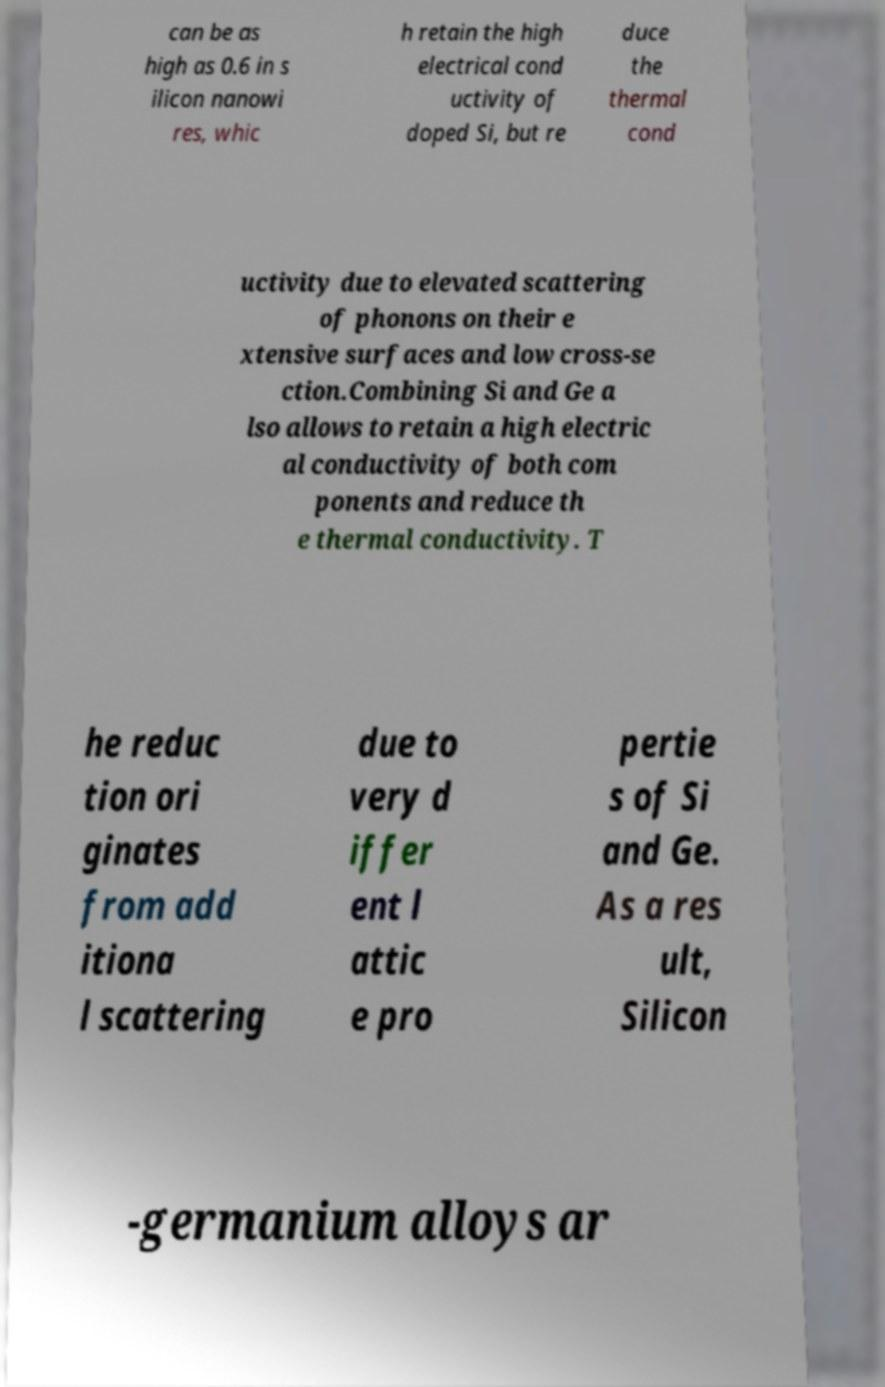Can you read and provide the text displayed in the image?This photo seems to have some interesting text. Can you extract and type it out for me? can be as high as 0.6 in s ilicon nanowi res, whic h retain the high electrical cond uctivity of doped Si, but re duce the thermal cond uctivity due to elevated scattering of phonons on their e xtensive surfaces and low cross-se ction.Combining Si and Ge a lso allows to retain a high electric al conductivity of both com ponents and reduce th e thermal conductivity. T he reduc tion ori ginates from add itiona l scattering due to very d iffer ent l attic e pro pertie s of Si and Ge. As a res ult, Silicon -germanium alloys ar 